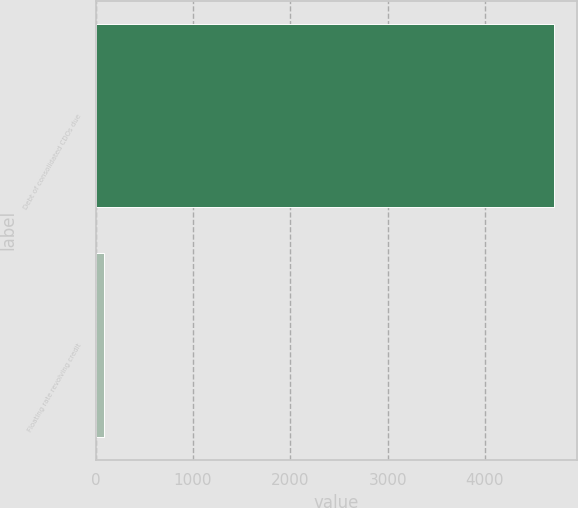Convert chart. <chart><loc_0><loc_0><loc_500><loc_500><bar_chart><fcel>Debt of consolidated CDOs due<fcel>Floating rate revolving credit<nl><fcel>4712<fcel>88<nl></chart> 